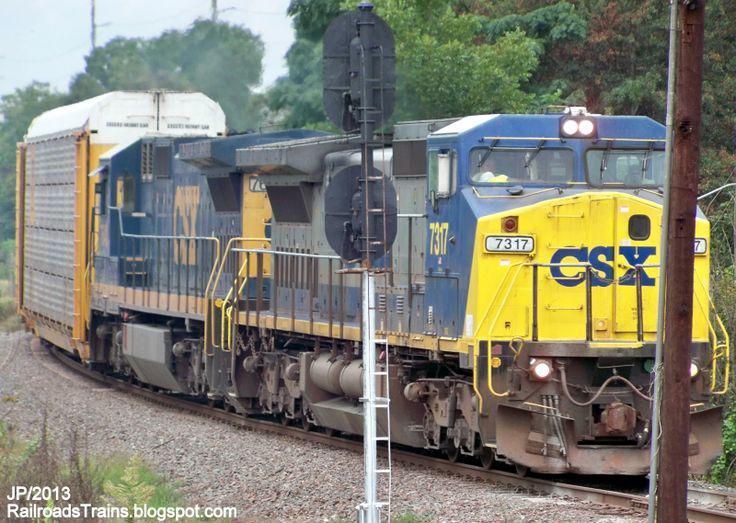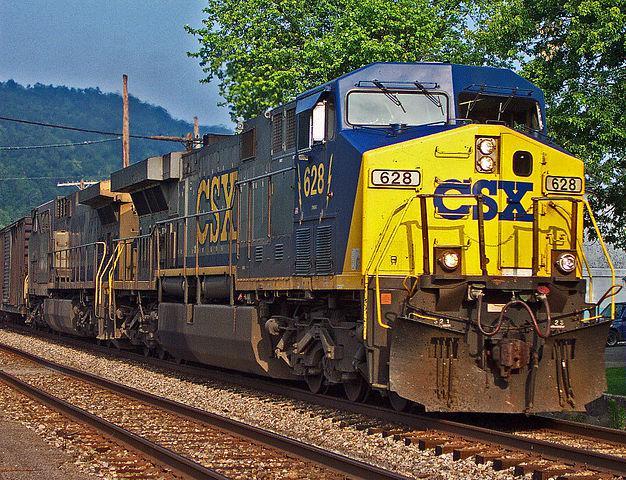The first image is the image on the left, the second image is the image on the right. Evaluate the accuracy of this statement regarding the images: "Left image shows a blue and yellow train that his heading rightward.". Is it true? Answer yes or no. Yes. The first image is the image on the left, the second image is the image on the right. Given the left and right images, does the statement "A total of two trains are headed on the same direction." hold true? Answer yes or no. Yes. 